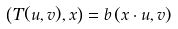<formula> <loc_0><loc_0><loc_500><loc_500>\left ( T ( u , v ) , x \right ) = b \left ( x \cdot u , v \right )</formula> 